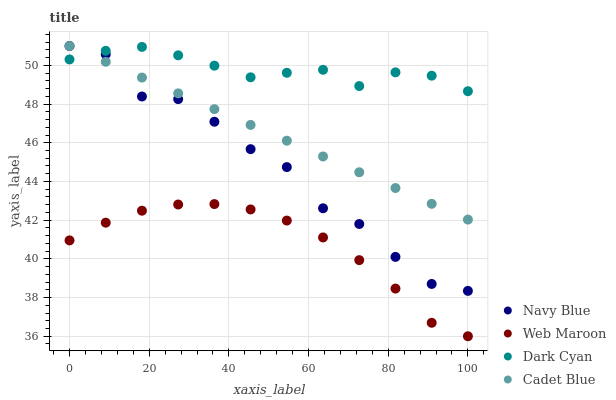Does Web Maroon have the minimum area under the curve?
Answer yes or no. Yes. Does Dark Cyan have the maximum area under the curve?
Answer yes or no. Yes. Does Navy Blue have the minimum area under the curve?
Answer yes or no. No. Does Navy Blue have the maximum area under the curve?
Answer yes or no. No. Is Cadet Blue the smoothest?
Answer yes or no. Yes. Is Navy Blue the roughest?
Answer yes or no. Yes. Is Navy Blue the smoothest?
Answer yes or no. No. Is Cadet Blue the roughest?
Answer yes or no. No. Does Web Maroon have the lowest value?
Answer yes or no. Yes. Does Navy Blue have the lowest value?
Answer yes or no. No. Does Cadet Blue have the highest value?
Answer yes or no. Yes. Does Web Maroon have the highest value?
Answer yes or no. No. Is Web Maroon less than Dark Cyan?
Answer yes or no. Yes. Is Navy Blue greater than Web Maroon?
Answer yes or no. Yes. Does Dark Cyan intersect Navy Blue?
Answer yes or no. Yes. Is Dark Cyan less than Navy Blue?
Answer yes or no. No. Is Dark Cyan greater than Navy Blue?
Answer yes or no. No. Does Web Maroon intersect Dark Cyan?
Answer yes or no. No. 